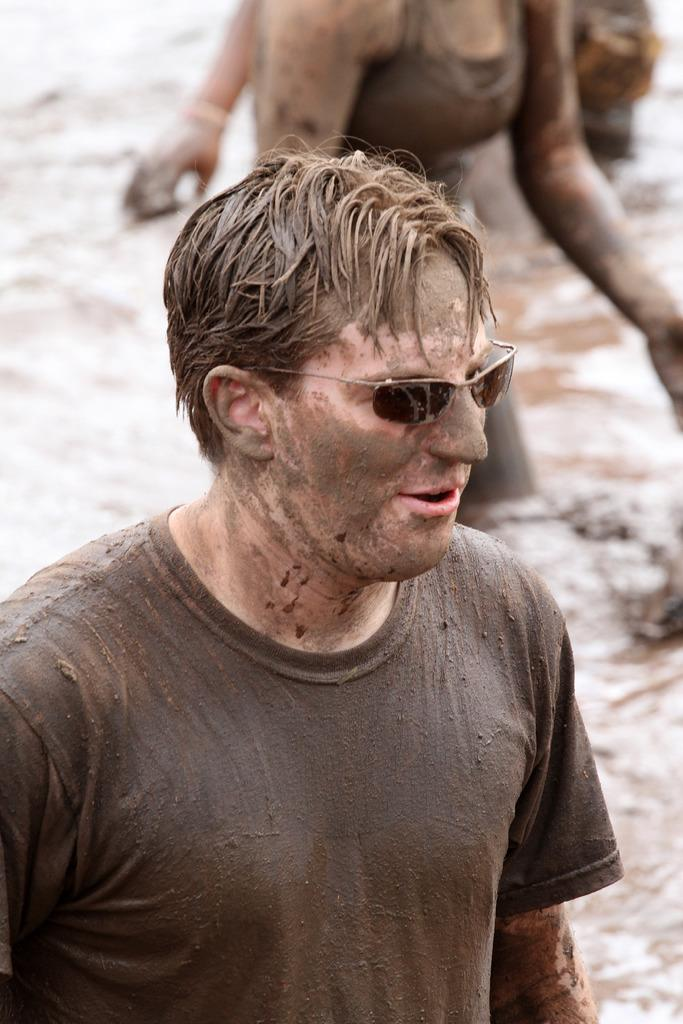How many people are in the image? There is a group of people in the image. Can you describe any specific clothing or accessories worn by someone in the group? One person in the group is wearing goggles. What type of animal is wearing a ring in the image? There is no animal or ring present in the image. 